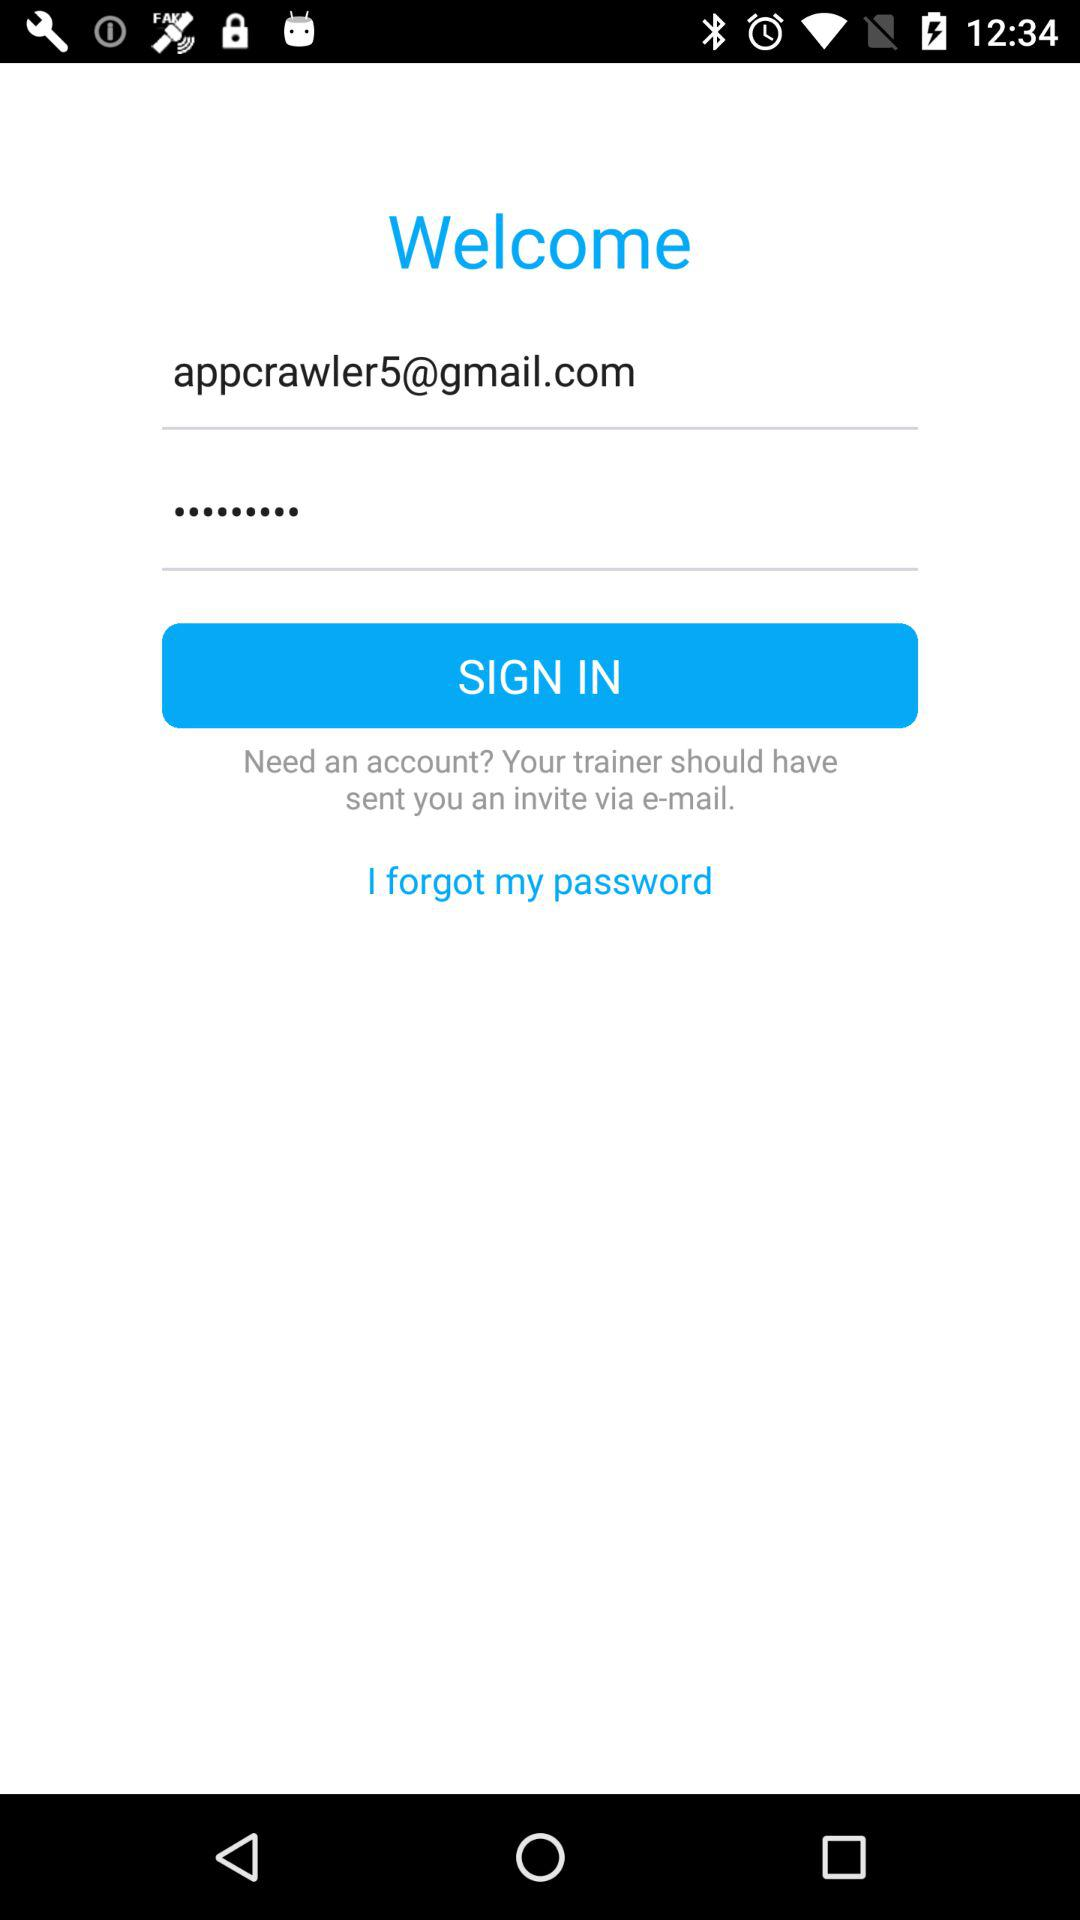What is the name of the application?
When the provided information is insufficient, respond with <no answer>. <no answer> 